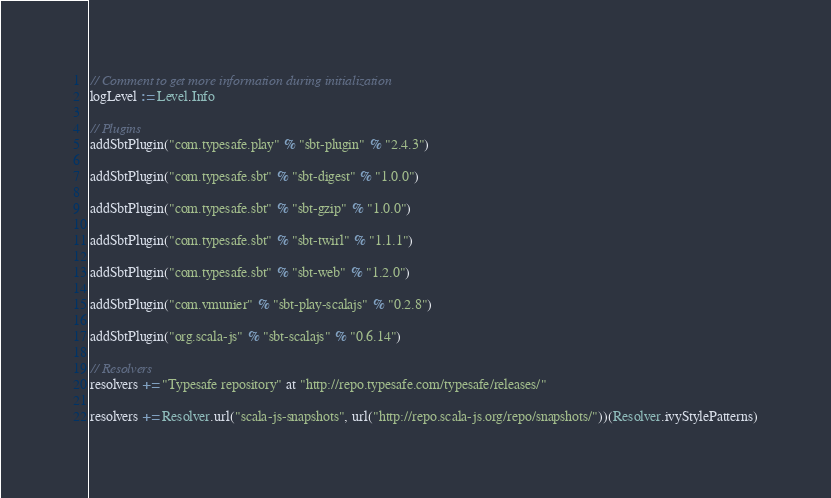<code> <loc_0><loc_0><loc_500><loc_500><_Scala_>// Comment to get more information during initialization
logLevel := Level.Info

// Plugins
addSbtPlugin("com.typesafe.play" % "sbt-plugin" % "2.4.3")

addSbtPlugin("com.typesafe.sbt" % "sbt-digest" % "1.0.0")

addSbtPlugin("com.typesafe.sbt" % "sbt-gzip" % "1.0.0")

addSbtPlugin("com.typesafe.sbt" % "sbt-twirl" % "1.1.1")

addSbtPlugin("com.typesafe.sbt" % "sbt-web" % "1.2.0")

addSbtPlugin("com.vmunier" % "sbt-play-scalajs" % "0.2.8")

addSbtPlugin("org.scala-js" % "sbt-scalajs" % "0.6.14")

// Resolvers
resolvers += "Typesafe repository" at "http://repo.typesafe.com/typesafe/releases/"

resolvers += Resolver.url("scala-js-snapshots", url("http://repo.scala-js.org/repo/snapshots/"))(Resolver.ivyStylePatterns)
</code> 